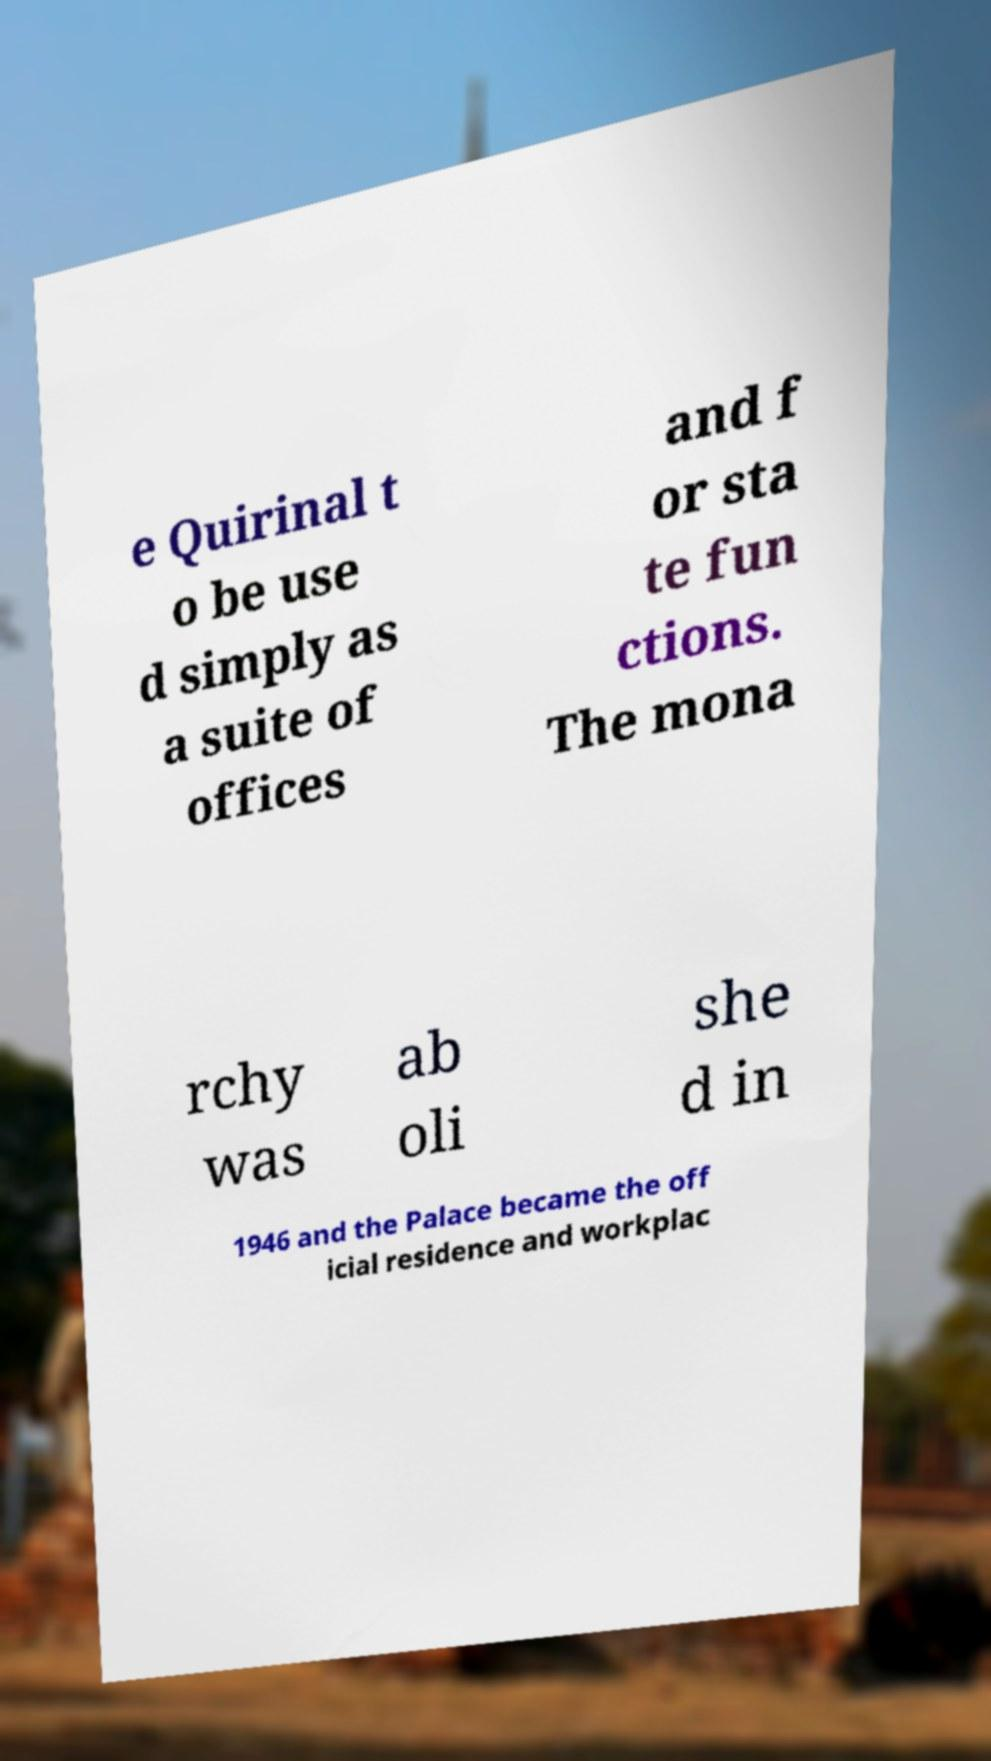I need the written content from this picture converted into text. Can you do that? e Quirinal t o be use d simply as a suite of offices and f or sta te fun ctions. The mona rchy was ab oli she d in 1946 and the Palace became the off icial residence and workplac 